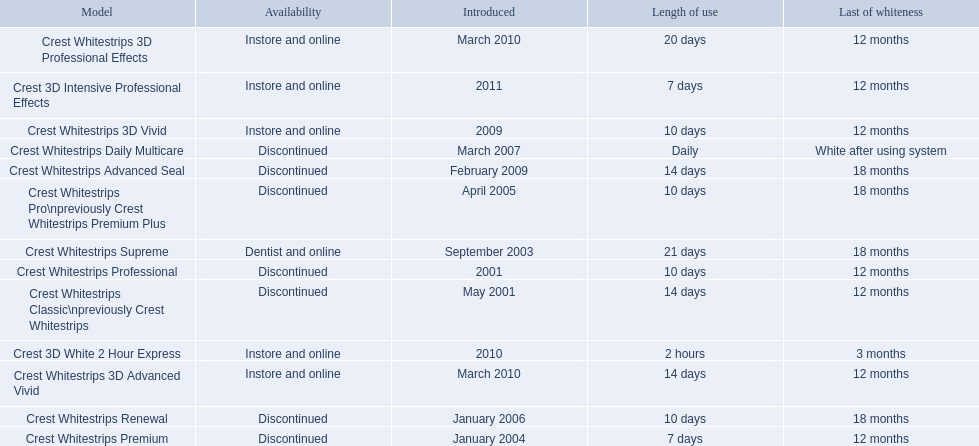Which models are still available? Crest Whitestrips Supreme, Crest Whitestrips 3D Vivid, Crest Whitestrips 3D Advanced Vivid, Crest Whitestrips 3D Professional Effects, Crest 3D White 2 Hour Express, Crest 3D Intensive Professional Effects. Of those, which were introduced prior to 2011? Crest Whitestrips Supreme, Crest Whitestrips 3D Vivid, Crest Whitestrips 3D Advanced Vivid, Crest Whitestrips 3D Professional Effects, Crest 3D White 2 Hour Express. Among those models, which ones had to be used at least 14 days? Crest Whitestrips Supreme, Crest Whitestrips 3D Advanced Vivid, Crest Whitestrips 3D Professional Effects. Which of those lasted longer than 12 months? Crest Whitestrips Supreme. 